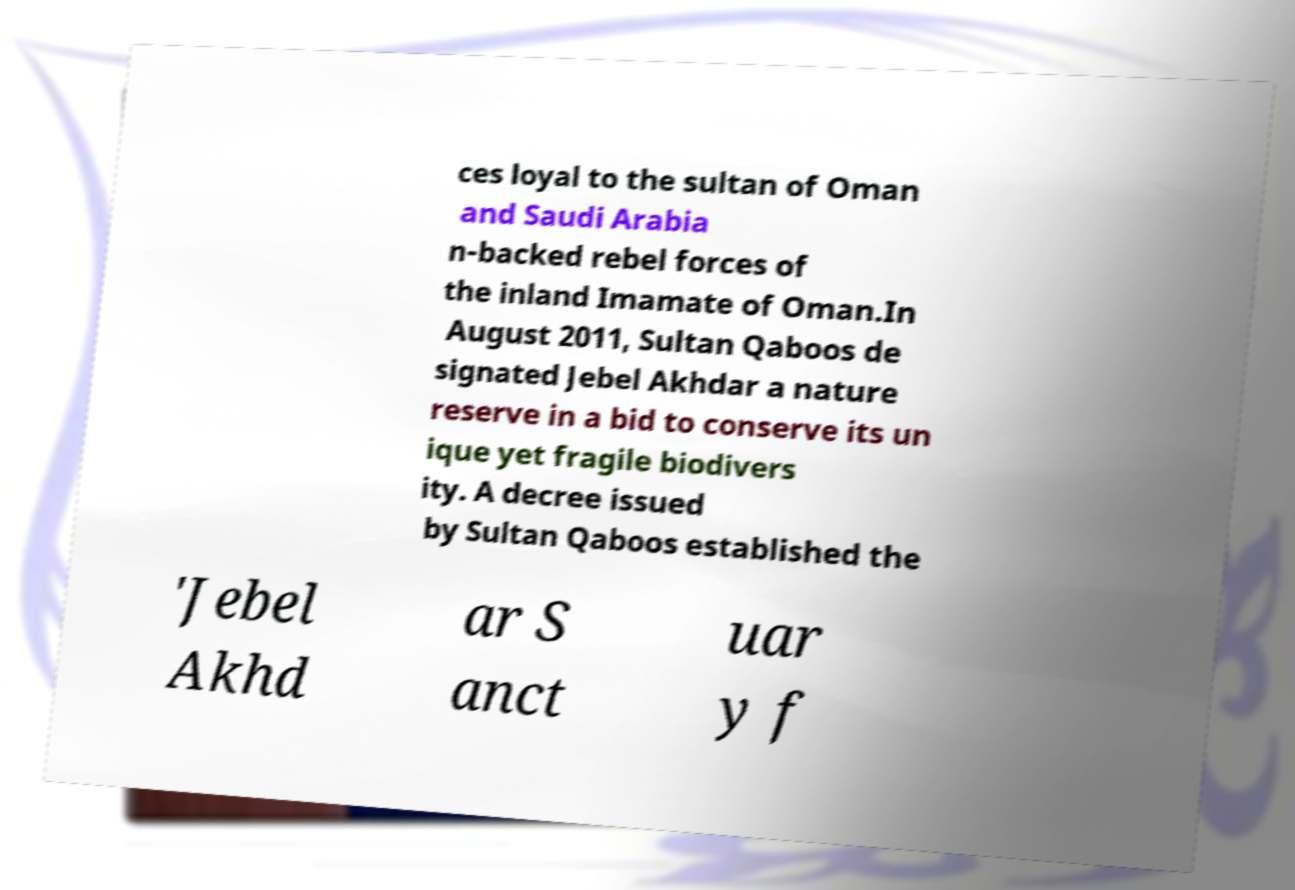Could you assist in decoding the text presented in this image and type it out clearly? ces loyal to the sultan of Oman and Saudi Arabia n-backed rebel forces of the inland Imamate of Oman.In August 2011, Sultan Qaboos de signated Jebel Akhdar a nature reserve in a bid to conserve its un ique yet fragile biodivers ity. A decree issued by Sultan Qaboos established the 'Jebel Akhd ar S anct uar y f 